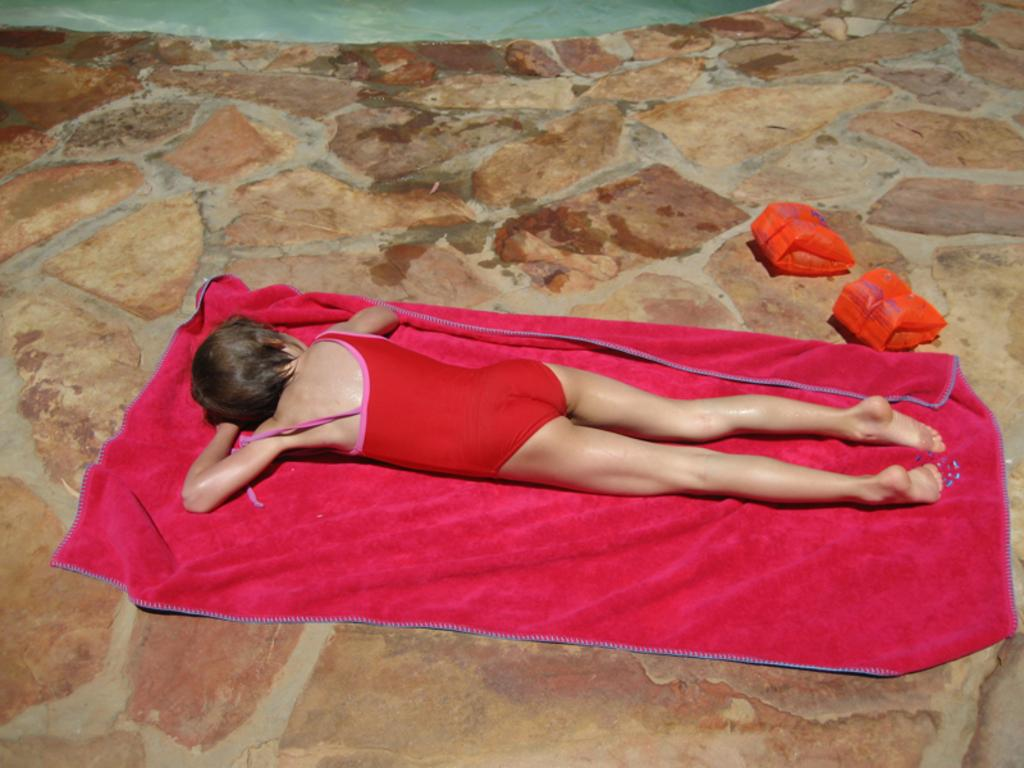What is the person in the image doing? The person is lying on a cloth in the image. What can be seen on the ground in the image? There are objects on the ground in the image. What type of idea is being woven by the wool in the image? There is no wool or idea present in the image; it only features a person lying on a cloth and objects on the ground. 